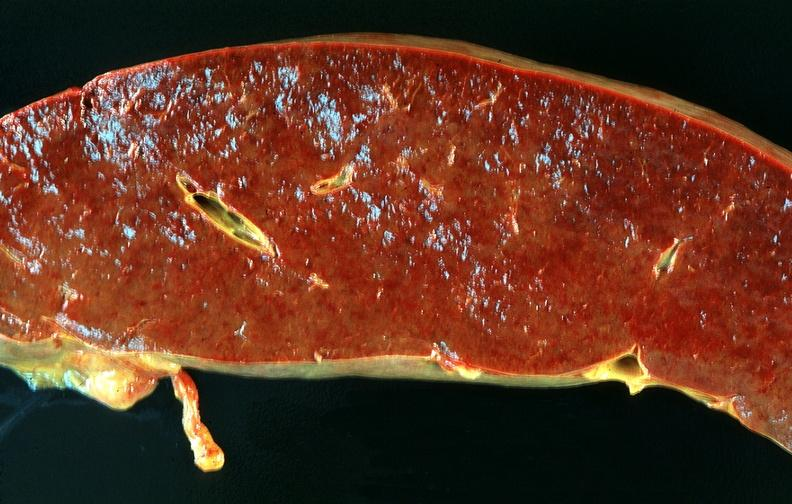what is present?
Answer the question using a single word or phrase. Hematologic 